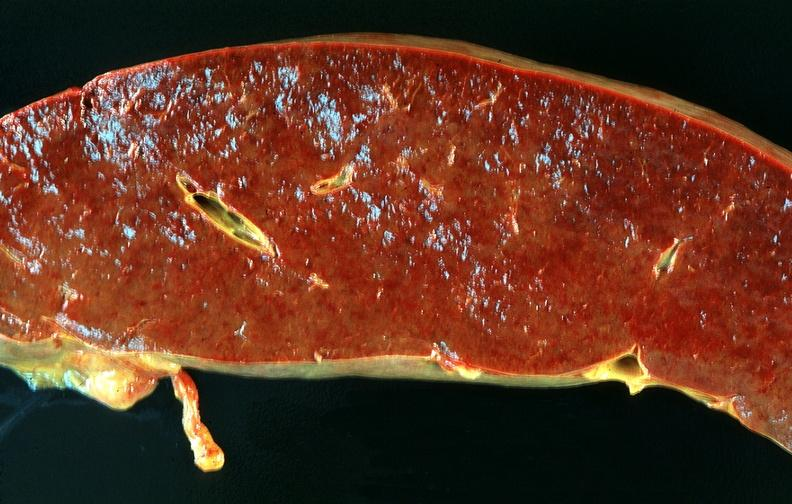what is present?
Answer the question using a single word or phrase. Hematologic 